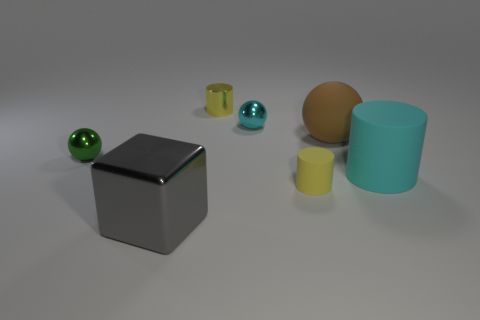Is the material of the tiny object to the left of the gray shiny block the same as the big cyan object? Upon examining the image, the tiny object to the left of the gray block appears to have a metallic sheen, indicating it is likely made of metal or a similar reflective material. In contrast, the larger cyan object has a matte surface, suggesting it could be made of plastic or another non-metallic material. Therefore, they do not appear to be made of the same material. 